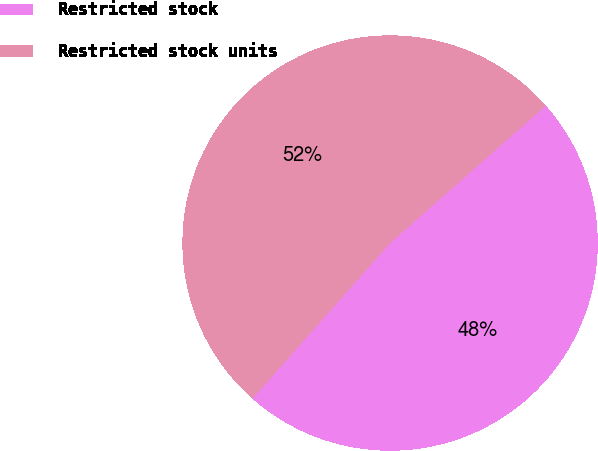Convert chart to OTSL. <chart><loc_0><loc_0><loc_500><loc_500><pie_chart><fcel>Restricted stock<fcel>Restricted stock units<nl><fcel>48.03%<fcel>51.97%<nl></chart> 